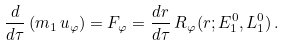<formula> <loc_0><loc_0><loc_500><loc_500>\frac { d } { d \tau } \, ( m _ { 1 } \, u _ { \varphi } ) = F _ { \varphi } = \frac { d r } { d \tau } \, R _ { \varphi } ( r ; E _ { 1 } ^ { 0 } , L _ { 1 } ^ { 0 } ) \, .</formula> 